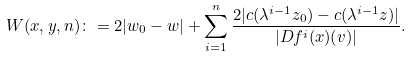<formula> <loc_0><loc_0><loc_500><loc_500>W ( x , y , n ) \colon = 2 | w _ { 0 } - w | + \sum _ { i = 1 } ^ { n } \frac { 2 | c ( \lambda ^ { i - 1 } z _ { 0 } ) - c ( \lambda ^ { i - 1 } z ) | } { | D f ^ { i } ( x ) ( v ) | } .</formula> 